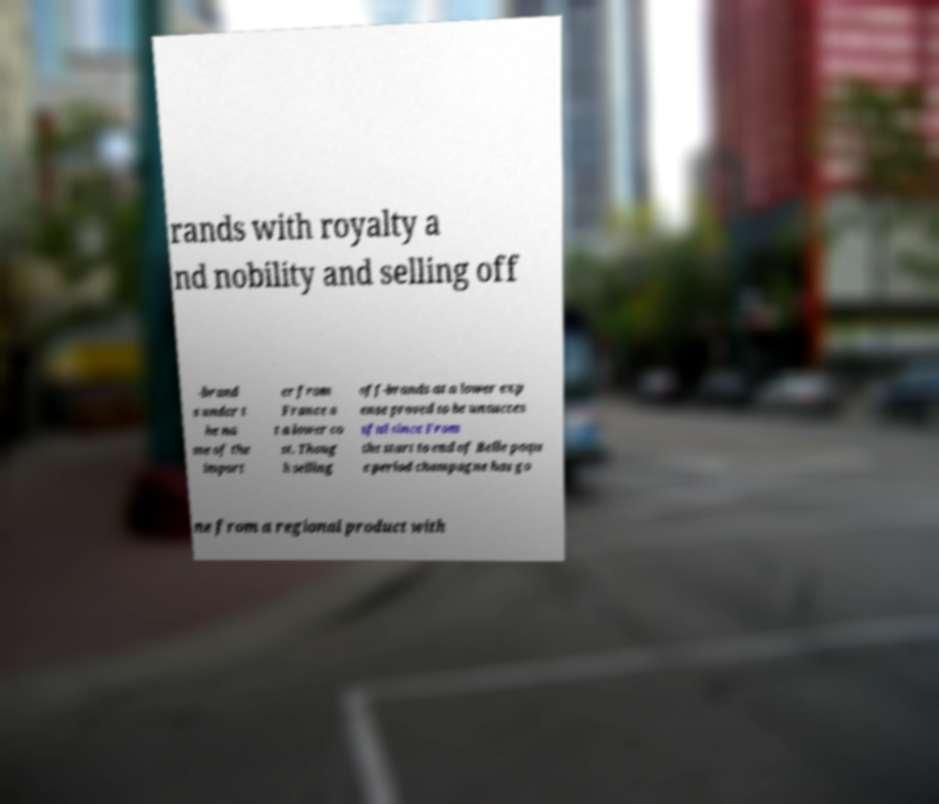Please identify and transcribe the text found in this image. rands with royalty a nd nobility and selling off -brand s under t he na me of the import er from France a t a lower co st. Thoug h selling off-brands at a lower exp ense proved to be unsucces sful since From the start to end of Belle poqu e period champagne has go ne from a regional product with 